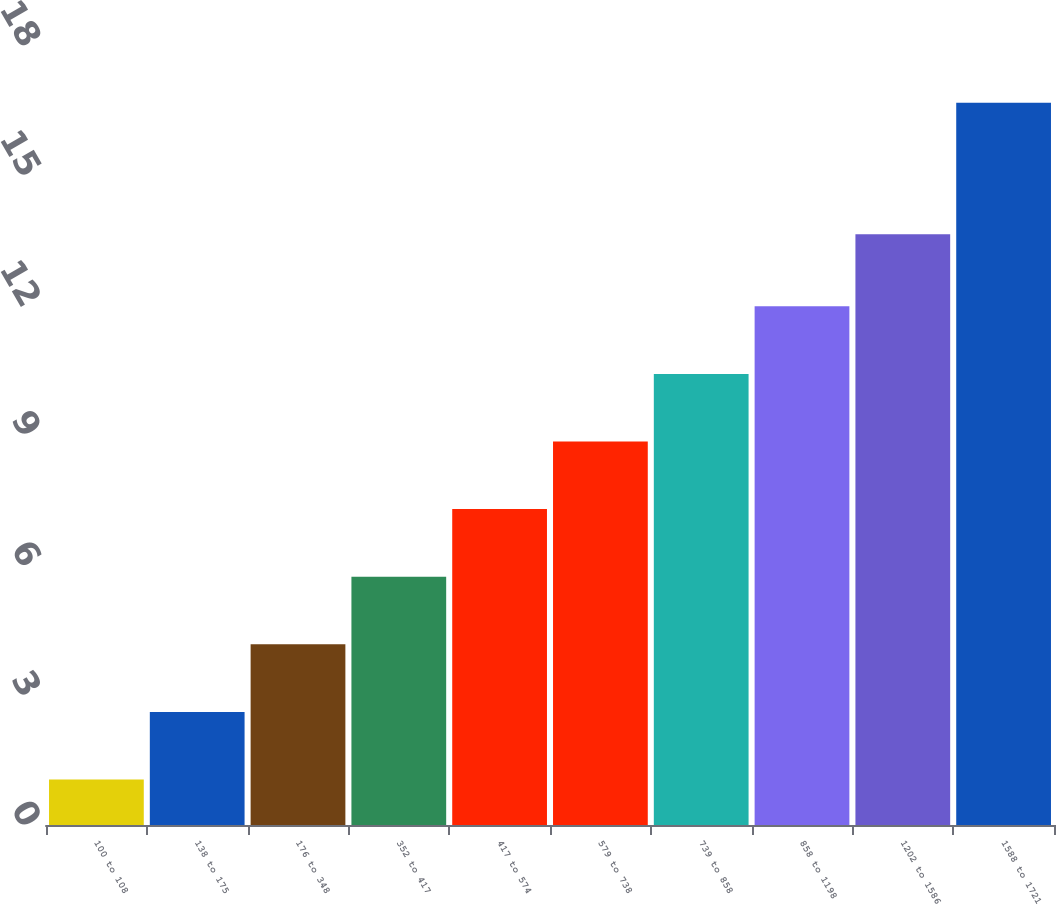Convert chart. <chart><loc_0><loc_0><loc_500><loc_500><bar_chart><fcel>100 to 108<fcel>138 to 175<fcel>176 to 348<fcel>352 to 417<fcel>417 to 574<fcel>579 to 738<fcel>739 to 858<fcel>858 to 1198<fcel>1202 to 1586<fcel>1588 to 1721<nl><fcel>1.05<fcel>2.61<fcel>4.17<fcel>5.73<fcel>7.29<fcel>8.85<fcel>10.41<fcel>11.97<fcel>13.63<fcel>16.67<nl></chart> 